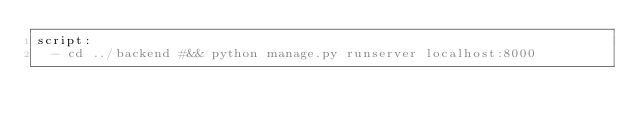Convert code to text. <code><loc_0><loc_0><loc_500><loc_500><_YAML_>script:
  - cd ../backend #&& python manage.py runserver localhost:8000</code> 